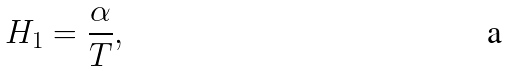<formula> <loc_0><loc_0><loc_500><loc_500>H _ { 1 } = \frac { \alpha } { T } ,</formula> 